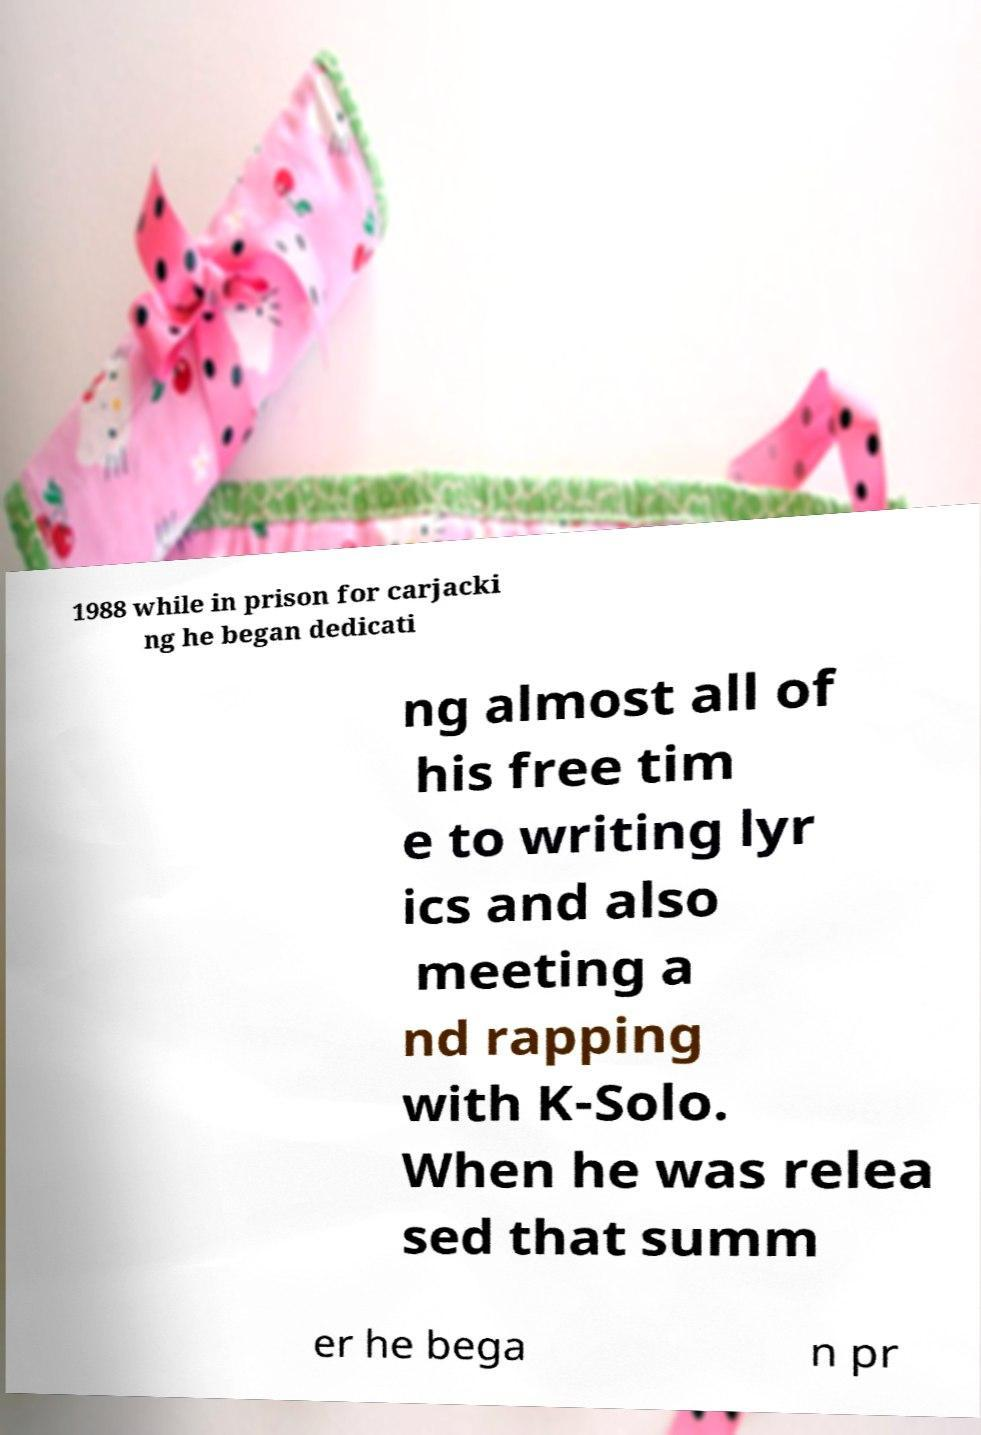Please identify and transcribe the text found in this image. 1988 while in prison for carjacki ng he began dedicati ng almost all of his free tim e to writing lyr ics and also meeting a nd rapping with K-Solo. When he was relea sed that summ er he bega n pr 